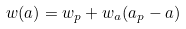<formula> <loc_0><loc_0><loc_500><loc_500>w ( a ) = w _ { p } + w _ { a } ( a _ { p } - a )</formula> 